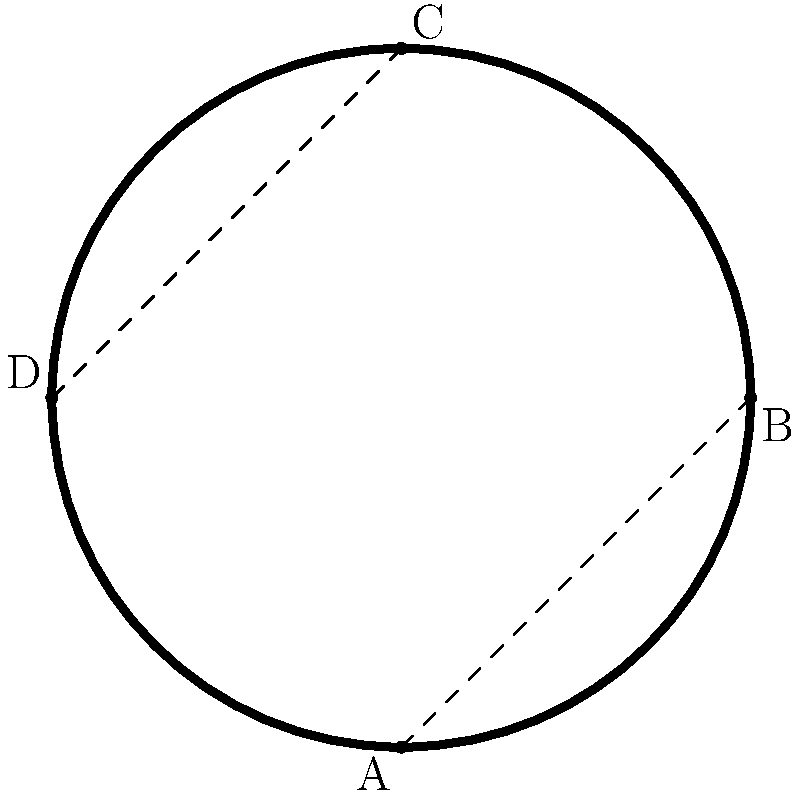A Symbolist-inspired art frame has a unique shape with intricate curves, as shown in the diagram. The frame can be approximated by four curved segments connecting points A, B, C, and D. If the length of each curved segment is 1.5 times the length of the straight line connecting its endpoints, and the diagonal distance from A to C is 5 cm, calculate the perimeter of the frame to the nearest centimeter. Let's approach this step-by-step:

1) First, we need to find the lengths of AB and BC (which are equal to CD and DA due to symmetry).

2) We can use the Pythagorean theorem to find AC:
   $AC^2 = AB^2 + BC^2$
   $5^2 = AB^2 + BC^2$
   $25 = 2AB^2$ (since AB = BC due to symmetry)
   $AB = \sqrt{\frac{25}{2}} = \frac{5}{\sqrt{2}} \approx 3.54$ cm

3) Now we know that each straight segment (AB, BC, CD, DA) is approximately 3.54 cm.

4) The question states that each curved segment is 1.5 times the length of its straight counterpart. So:
   Curved segment length = $1.5 \times 3.54 = 5.31$ cm

5) There are four curved segments, so the total perimeter is:
   Perimeter = $4 \times 5.31 = 21.24$ cm

6) Rounding to the nearest centimeter gives us 21 cm.
Answer: 21 cm 